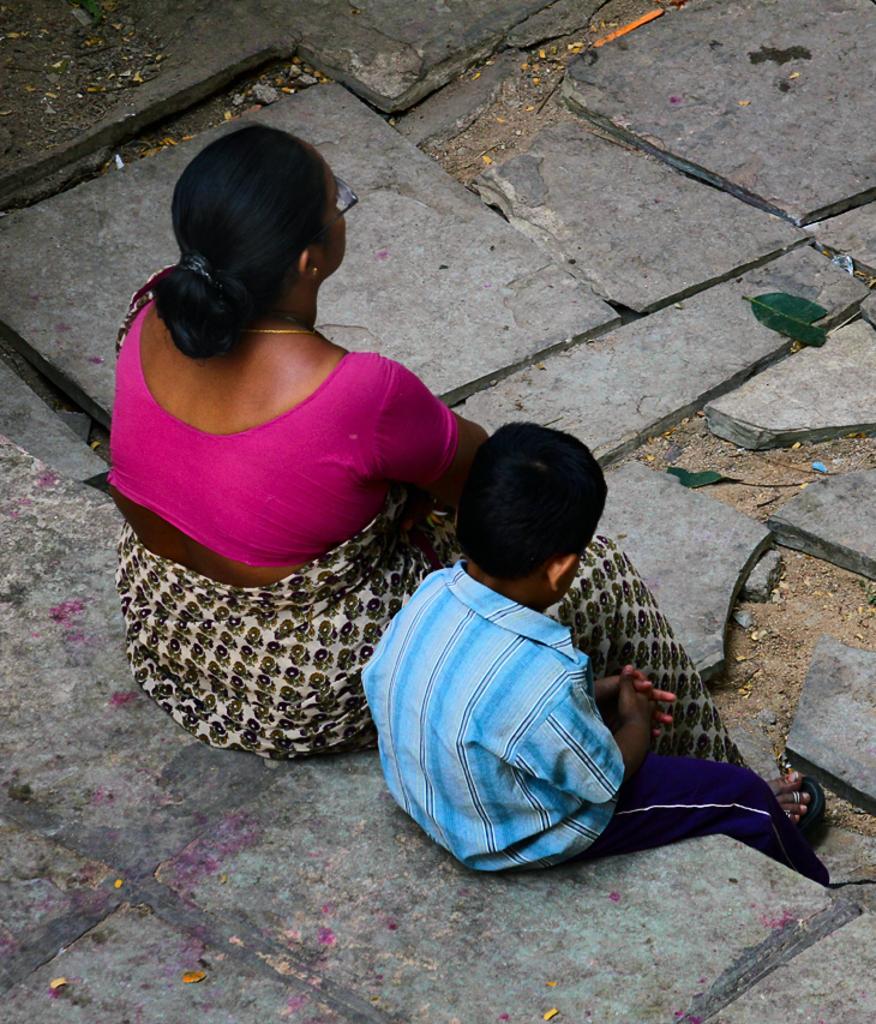In one or two sentences, can you explain what this image depicts? In this image, we can see two persons wearing clothes. In these two persons, one of them is a kid. There are some granite tiles on the ground. 